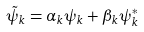Convert formula to latex. <formula><loc_0><loc_0><loc_500><loc_500>\tilde { \psi } _ { k } = \alpha _ { k } \psi _ { k } + \beta _ { k } \psi _ { k } ^ { * }</formula> 